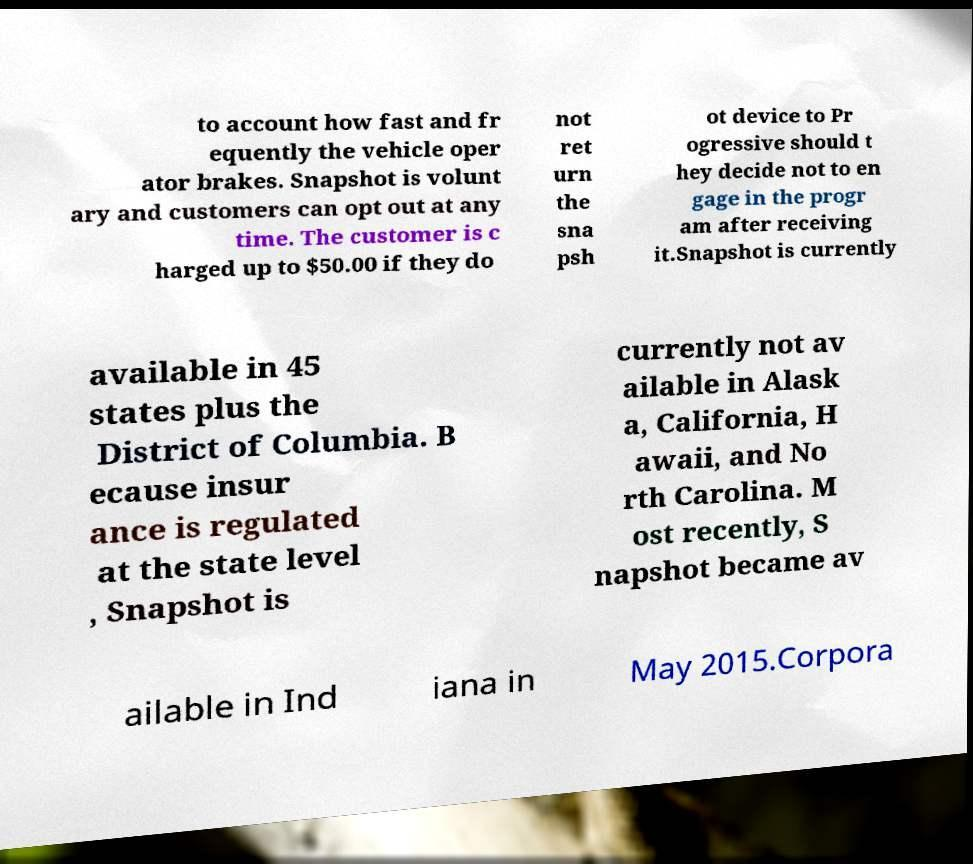Can you accurately transcribe the text from the provided image for me? to account how fast and fr equently the vehicle oper ator brakes. Snapshot is volunt ary and customers can opt out at any time. The customer is c harged up to $50.00 if they do not ret urn the sna psh ot device to Pr ogressive should t hey decide not to en gage in the progr am after receiving it.Snapshot is currently available in 45 states plus the District of Columbia. B ecause insur ance is regulated at the state level , Snapshot is currently not av ailable in Alask a, California, H awaii, and No rth Carolina. M ost recently, S napshot became av ailable in Ind iana in May 2015.Corpora 